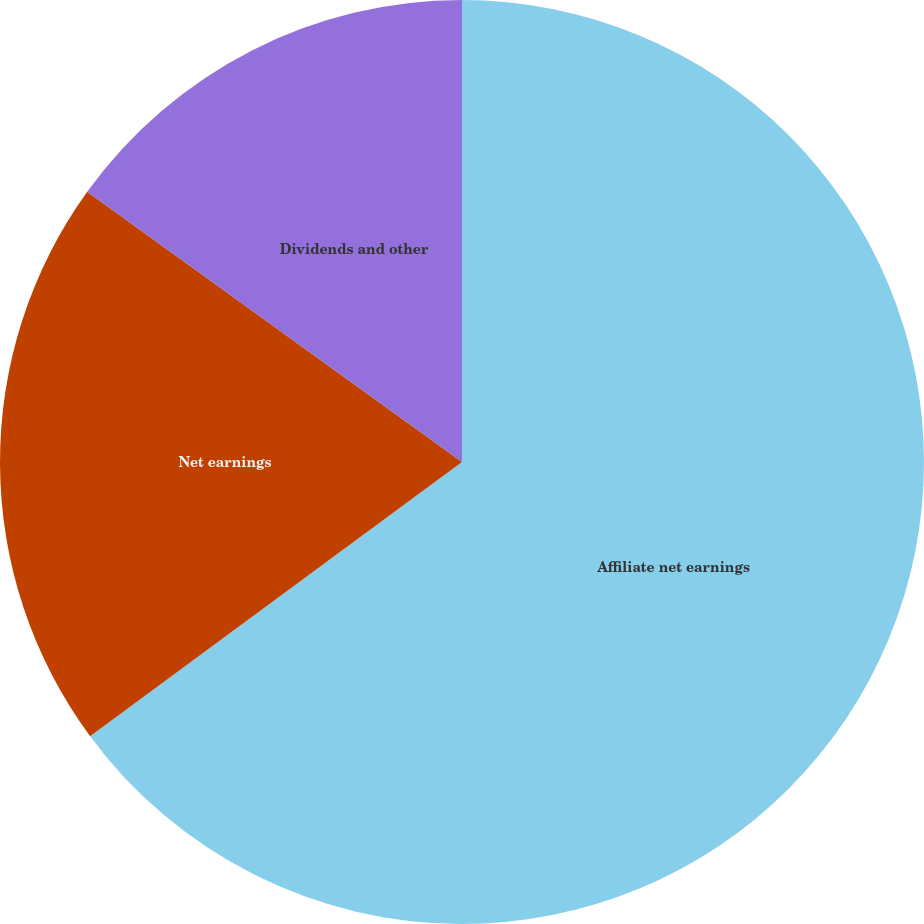Convert chart. <chart><loc_0><loc_0><loc_500><loc_500><pie_chart><fcel>Affiliate net earnings<fcel>Net earnings<fcel>Dividends and other<nl><fcel>64.89%<fcel>20.05%<fcel>15.06%<nl></chart> 